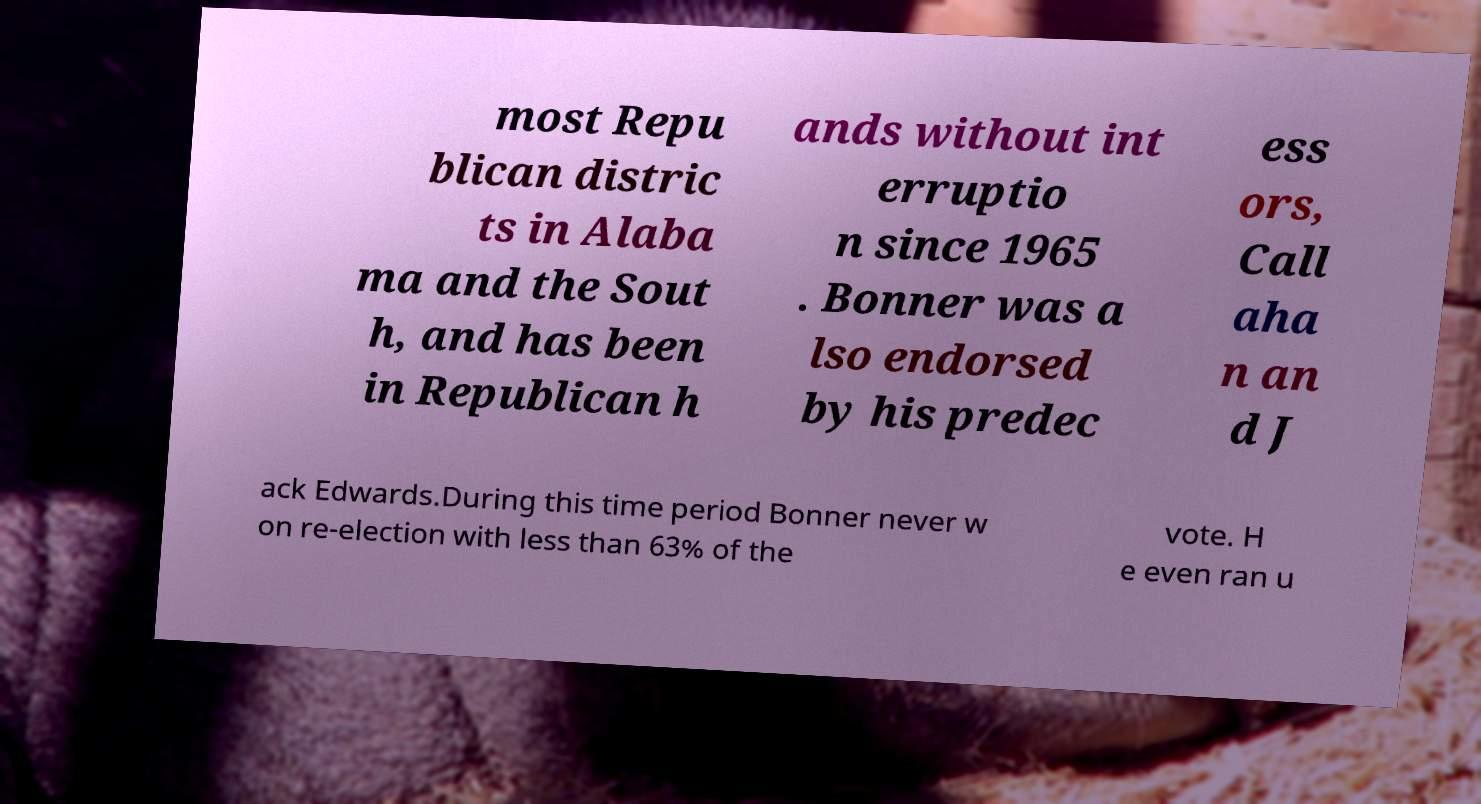Please identify and transcribe the text found in this image. most Repu blican distric ts in Alaba ma and the Sout h, and has been in Republican h ands without int erruptio n since 1965 . Bonner was a lso endorsed by his predec ess ors, Call aha n an d J ack Edwards.During this time period Bonner never w on re-election with less than 63% of the vote. H e even ran u 